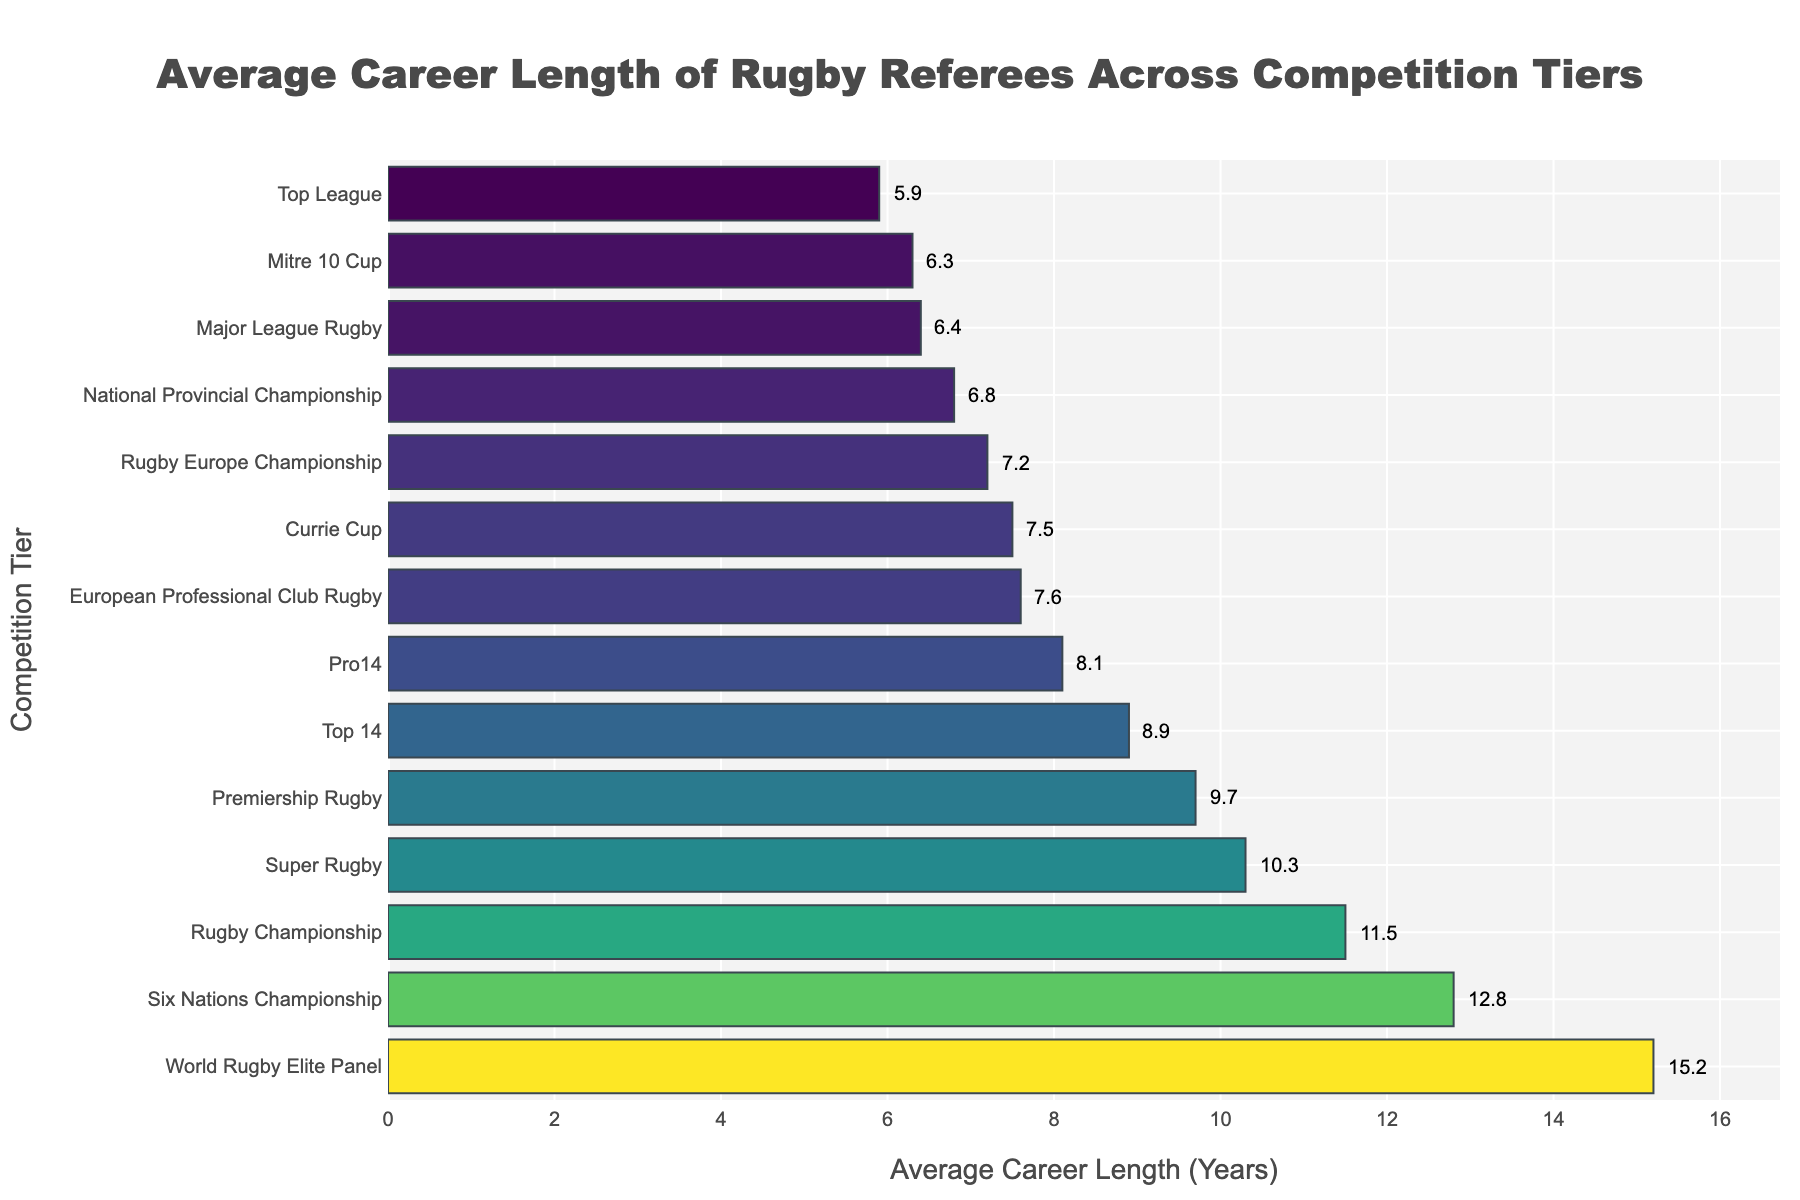Which competition tier has the longest average career length for rugby referees? The competition tier with the longest bar in the chart represents the highest average career length.
Answer: World Rugby Elite Panel Which competition tier has the shortest average career length for rugby referees? The competition tier with the shortest bar in the chart represents the lowest average career length.
Answer: Top League How many competition tiers have an average career length of more than 10 years? Count the number of bars that extend beyond the 10-year mark on the x-axis.
Answer: 4 What is the difference in average career length between the World Rugby Elite Panel and Rugby Championship? Subtract the average career length of the Rugby Championship from that of the World Rugby Elite Panel: 15.2 - 11.5.
Answer: 3.7 years Is the average career length of referees in the Premiership Rugby longer or shorter than in the Top 14? Compare the lengths of the bars for Premiership Rugby and Top 14 to determine which is longer.
Answer: Longer What is the combined average career length of referees in Major League Rugby and Mitre 10 Cup? Add the average career lengths for Major League Rugby and Mitre 10 Cup: 6.4 + 6.3.
Answer: 12.7 years Which competition tier has a more similar average career length to the European Professional Club Rugby: Currie Cup or Rugby Europe Championship? Compare the lengths of the bars for Currie Cup and Rugby Europe Championship to see which one is closer to the bar for European Professional Club Rugby.
Answer: Currie Cup Identify the competition tier with the third highest average career length. After World Rugby Elite Panel and Six Nations Championship, check which bar is the next longest.
Answer: Rugby Championship How much longer is the average career length of referees in Six Nations Championship compared to Pro14? Subtract the average career length of Pro14 from Six Nations Championship: 12.8 - 8.1.
Answer: 4.7 years 